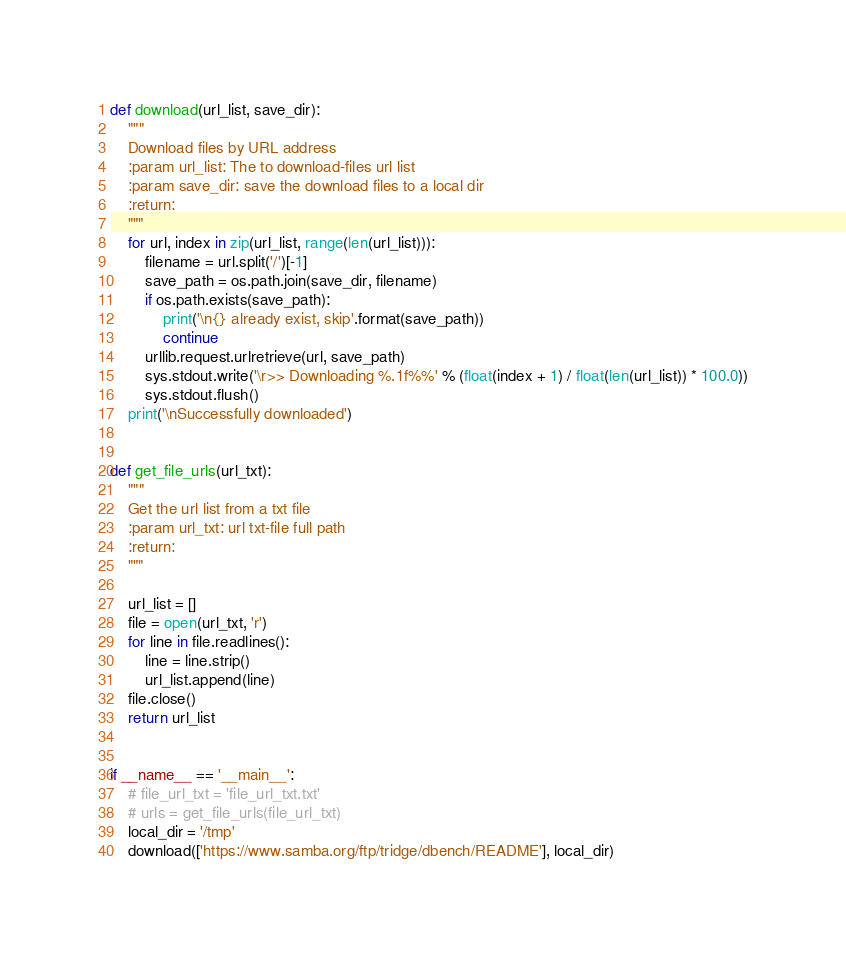<code> <loc_0><loc_0><loc_500><loc_500><_Python_>
def download(url_list, save_dir):
    """
    Download files by URL address
    :param url_list: The to download-files url list
    :param save_dir: save the download files to a local dir
    :return:
    """
    for url, index in zip(url_list, range(len(url_list))):
        filename = url.split('/')[-1]
        save_path = os.path.join(save_dir, filename)
        if os.path.exists(save_path):
            print('\n{} already exist, skip'.format(save_path))
            continue
        urllib.request.urlretrieve(url, save_path)
        sys.stdout.write('\r>> Downloading %.1f%%' % (float(index + 1) / float(len(url_list)) * 100.0))
        sys.stdout.flush()
    print('\nSuccessfully downloaded')


def get_file_urls(url_txt):
    """
    Get the url list from a txt file
    :param url_txt: url txt-file full path
    :return:
    """

    url_list = []
    file = open(url_txt, 'r')
    for line in file.readlines():
        line = line.strip()
        url_list.append(line)
    file.close()
    return url_list


if __name__ == '__main__':
    # file_url_txt = 'file_url_txt.txt'
    # urls = get_file_urls(file_url_txt)
    local_dir = '/tmp'
    download(['https://www.samba.org/ftp/tridge/dbench/README'], local_dir)
</code> 